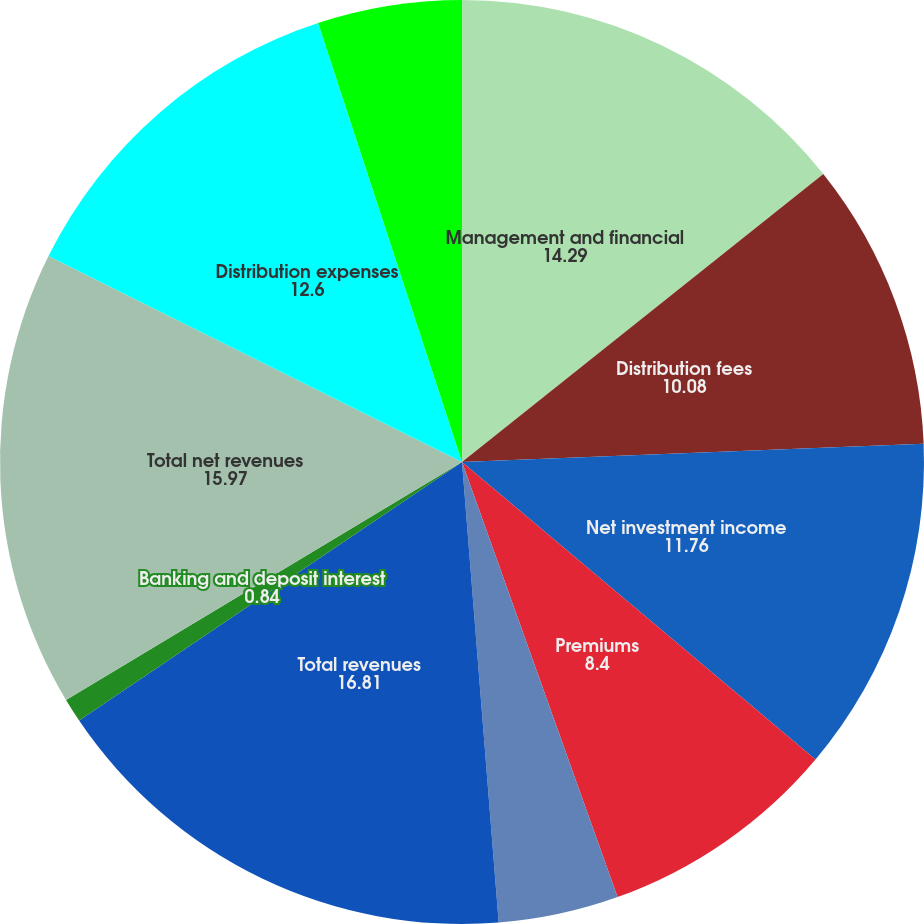<chart> <loc_0><loc_0><loc_500><loc_500><pie_chart><fcel>Management and financial<fcel>Distribution fees<fcel>Net investment income<fcel>Premiums<fcel>Other revenues<fcel>Total revenues<fcel>Banking and deposit interest<fcel>Total net revenues<fcel>Distribution expenses<fcel>Interest credited to fixed<nl><fcel>14.29%<fcel>10.08%<fcel>11.76%<fcel>8.4%<fcel>4.2%<fcel>16.81%<fcel>0.84%<fcel>15.97%<fcel>12.6%<fcel>5.04%<nl></chart> 